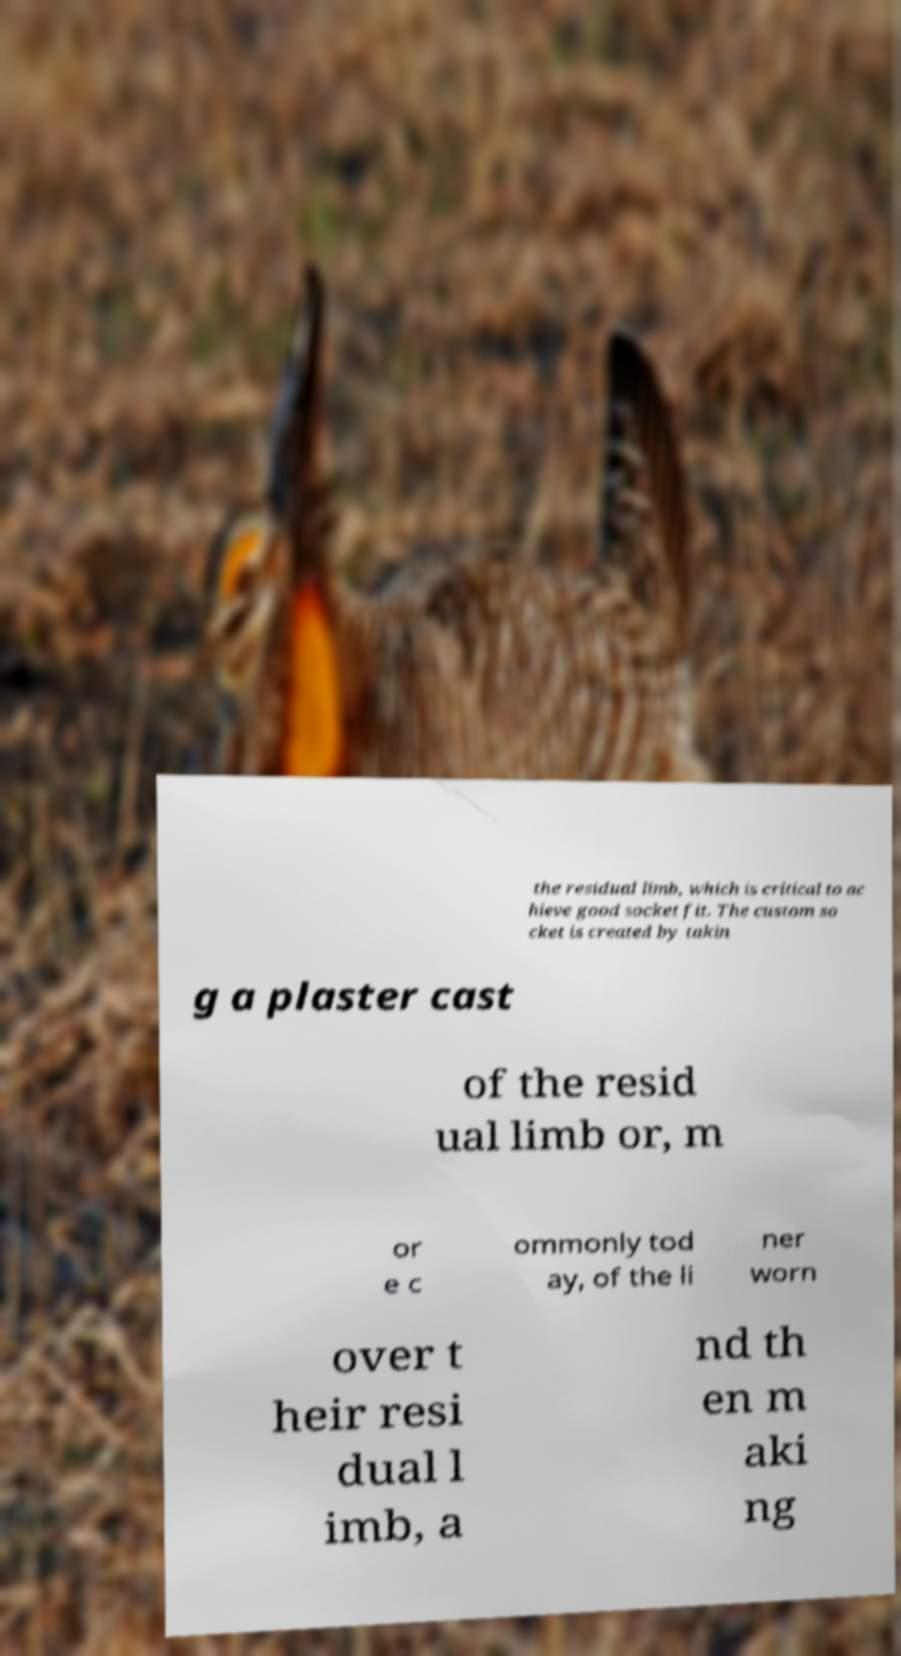Could you extract and type out the text from this image? the residual limb, which is critical to ac hieve good socket fit. The custom so cket is created by takin g a plaster cast of the resid ual limb or, m or e c ommonly tod ay, of the li ner worn over t heir resi dual l imb, a nd th en m aki ng 